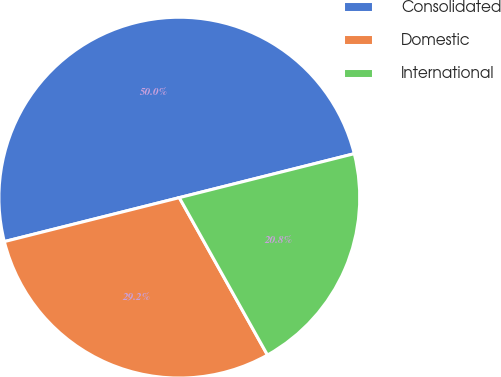Convert chart to OTSL. <chart><loc_0><loc_0><loc_500><loc_500><pie_chart><fcel>Consolidated<fcel>Domestic<fcel>International<nl><fcel>50.0%<fcel>29.21%<fcel>20.79%<nl></chart> 